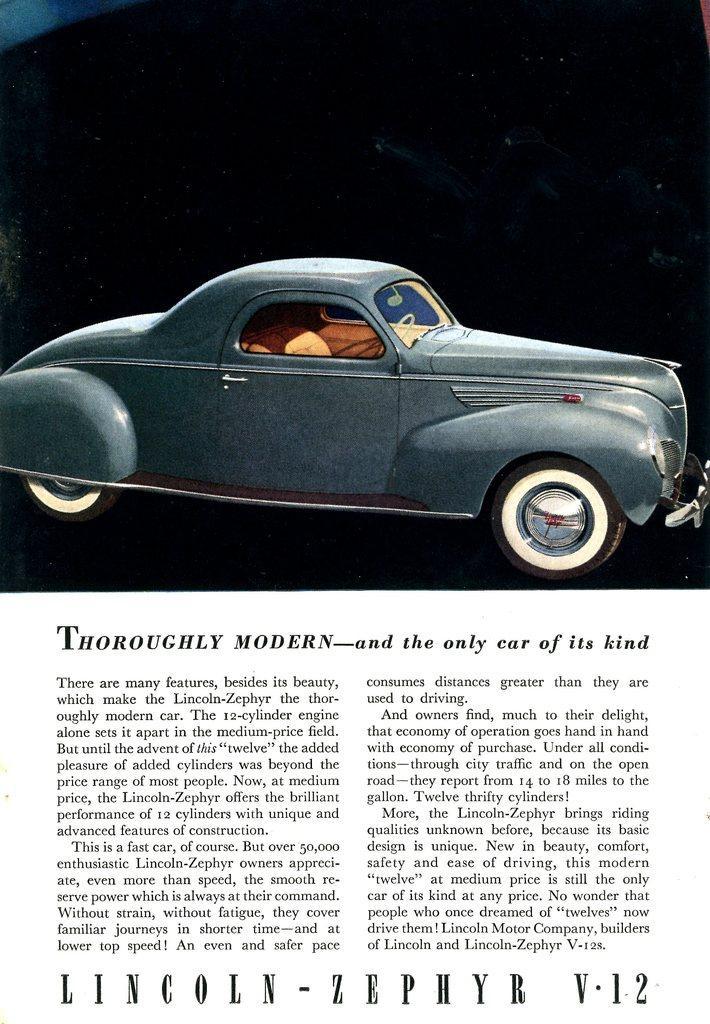How would you summarize this image in a sentence or two? As we can see in the image there is a paper. On paper there is some matter written and a grey color car. 